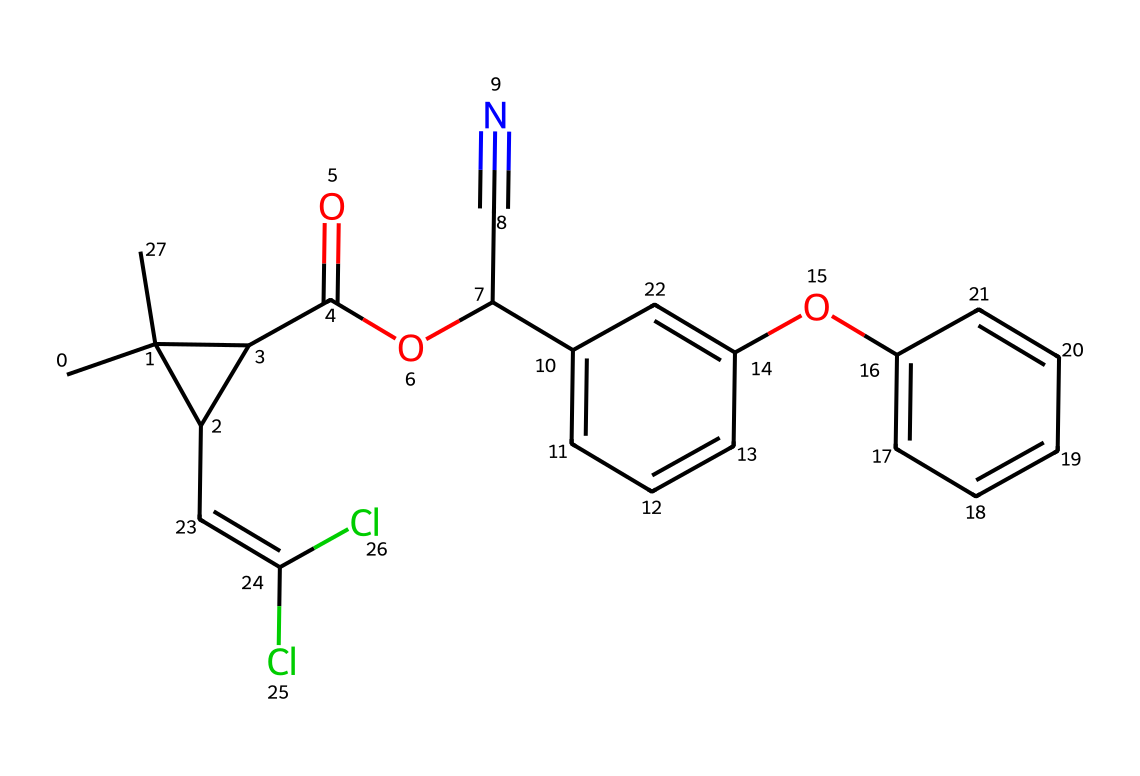What is the name of this chemical? The SMILES representation describes permethrin, a synthetic pyrethroid. The structure confirms this through the presence of a cyclopropane ring and a series of aromatic rings typical of pyrethroids.
Answer: permethrin How many chlorine atoms are present in the structure? The SMILES shows the presence of "Cl" symbols, indicating chlorine atoms. By counting those symbols, we find that there are two chlorine atoms present in the structure.
Answer: two What functional groups are present in the chemical? The SMILES representation contains an ester group (noted by "OC") and an aromatic hydroxyl group (the "O" in "Oc" indicates a hydroxy attached to a benzene ring). These groups play significant roles in the chemical's properties.
Answer: ester, hydroxyl What is the total number of carbon atoms in the chemical? To determine the number of carbon atoms, we count all occurrences of "C" in the SMILES representation, which gives a total count of 17 carbon atoms in the structure.
Answer: seventeen Which part of this chemical contributes to its insecticidal properties? The presence of the cyclopropane and aromatic rings along with the ester function in permethrin indicates its connection to pyrethroid characteristics. These groups contribute to its effectiveness as an insecticide by disrupting neural function in pests.
Answer: cyclopropane and aromatic rings How many double bonds are present in this chemical? In the SMILES, we are looking for "C=C" which indicates a double bond in the structure. By examining the formula, we see there is one double bond present in the molecule.
Answer: one 